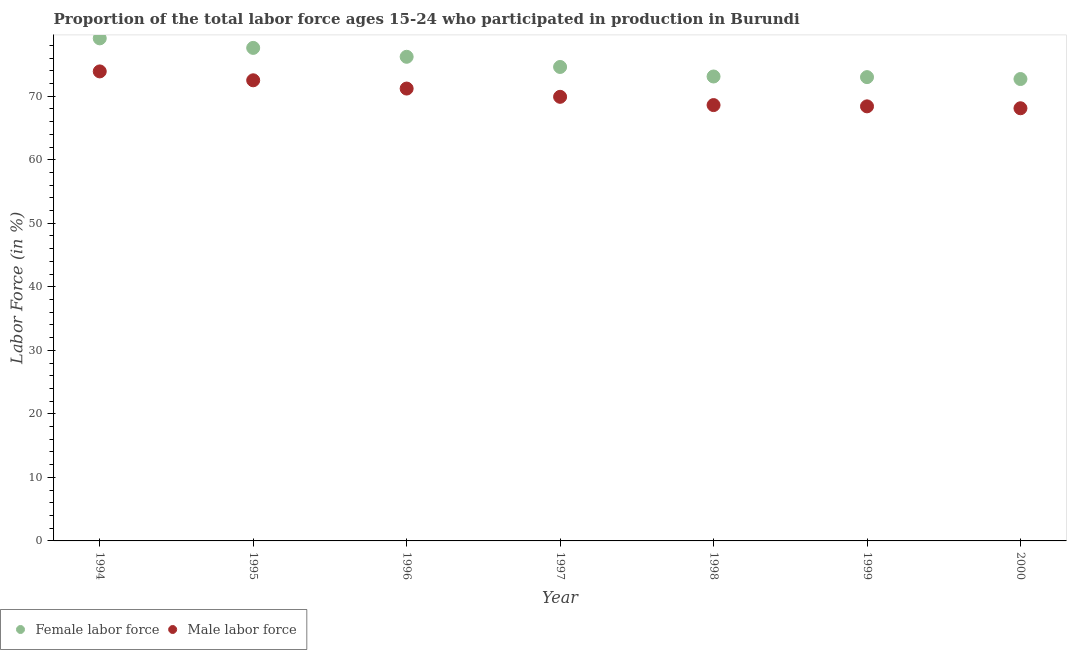Is the number of dotlines equal to the number of legend labels?
Offer a terse response. Yes. What is the percentage of male labour force in 1999?
Keep it short and to the point. 68.4. Across all years, what is the maximum percentage of male labour force?
Provide a short and direct response. 73.9. Across all years, what is the minimum percentage of female labor force?
Your answer should be compact. 72.7. In which year was the percentage of male labour force maximum?
Make the answer very short. 1994. In which year was the percentage of female labor force minimum?
Your answer should be compact. 2000. What is the total percentage of male labour force in the graph?
Make the answer very short. 492.6. What is the difference between the percentage of male labour force in 1994 and that in 1997?
Keep it short and to the point. 4. What is the difference between the percentage of male labour force in 1999 and the percentage of female labor force in 1998?
Offer a very short reply. -4.7. What is the average percentage of male labour force per year?
Ensure brevity in your answer.  70.37. In the year 1999, what is the difference between the percentage of female labor force and percentage of male labour force?
Your answer should be compact. 4.6. What is the ratio of the percentage of male labour force in 1994 to that in 1998?
Ensure brevity in your answer.  1.08. Is the percentage of female labor force in 1998 less than that in 2000?
Provide a succinct answer. No. Is the difference between the percentage of male labour force in 1996 and 1998 greater than the difference between the percentage of female labor force in 1996 and 1998?
Provide a short and direct response. No. What is the difference between the highest and the second highest percentage of male labour force?
Offer a very short reply. 1.4. What is the difference between the highest and the lowest percentage of female labor force?
Ensure brevity in your answer.  6.4. Is the percentage of male labour force strictly greater than the percentage of female labor force over the years?
Your response must be concise. No. How many years are there in the graph?
Provide a succinct answer. 7. Are the values on the major ticks of Y-axis written in scientific E-notation?
Your answer should be very brief. No. Does the graph contain any zero values?
Your response must be concise. No. Where does the legend appear in the graph?
Offer a terse response. Bottom left. How many legend labels are there?
Your answer should be very brief. 2. How are the legend labels stacked?
Offer a very short reply. Horizontal. What is the title of the graph?
Your answer should be very brief. Proportion of the total labor force ages 15-24 who participated in production in Burundi. What is the label or title of the X-axis?
Your response must be concise. Year. What is the Labor Force (in %) in Female labor force in 1994?
Your answer should be compact. 79.1. What is the Labor Force (in %) in Male labor force in 1994?
Make the answer very short. 73.9. What is the Labor Force (in %) of Female labor force in 1995?
Offer a terse response. 77.6. What is the Labor Force (in %) in Male labor force in 1995?
Your answer should be very brief. 72.5. What is the Labor Force (in %) of Female labor force in 1996?
Make the answer very short. 76.2. What is the Labor Force (in %) of Male labor force in 1996?
Your answer should be very brief. 71.2. What is the Labor Force (in %) of Female labor force in 1997?
Make the answer very short. 74.6. What is the Labor Force (in %) of Male labor force in 1997?
Offer a very short reply. 69.9. What is the Labor Force (in %) of Female labor force in 1998?
Give a very brief answer. 73.1. What is the Labor Force (in %) in Male labor force in 1998?
Keep it short and to the point. 68.6. What is the Labor Force (in %) in Male labor force in 1999?
Ensure brevity in your answer.  68.4. What is the Labor Force (in %) in Female labor force in 2000?
Provide a short and direct response. 72.7. What is the Labor Force (in %) of Male labor force in 2000?
Provide a succinct answer. 68.1. Across all years, what is the maximum Labor Force (in %) of Female labor force?
Offer a terse response. 79.1. Across all years, what is the maximum Labor Force (in %) of Male labor force?
Give a very brief answer. 73.9. Across all years, what is the minimum Labor Force (in %) of Female labor force?
Provide a short and direct response. 72.7. Across all years, what is the minimum Labor Force (in %) in Male labor force?
Give a very brief answer. 68.1. What is the total Labor Force (in %) of Female labor force in the graph?
Ensure brevity in your answer.  526.3. What is the total Labor Force (in %) in Male labor force in the graph?
Ensure brevity in your answer.  492.6. What is the difference between the Labor Force (in %) of Female labor force in 1994 and that in 1996?
Provide a short and direct response. 2.9. What is the difference between the Labor Force (in %) in Female labor force in 1994 and that in 1997?
Provide a short and direct response. 4.5. What is the difference between the Labor Force (in %) in Male labor force in 1994 and that in 1998?
Ensure brevity in your answer.  5.3. What is the difference between the Labor Force (in %) of Male labor force in 1994 and that in 2000?
Provide a succinct answer. 5.8. What is the difference between the Labor Force (in %) of Female labor force in 1995 and that in 1996?
Provide a short and direct response. 1.4. What is the difference between the Labor Force (in %) of Male labor force in 1995 and that in 1997?
Keep it short and to the point. 2.6. What is the difference between the Labor Force (in %) in Female labor force in 1995 and that in 1998?
Your response must be concise. 4.5. What is the difference between the Labor Force (in %) of Male labor force in 1995 and that in 2000?
Provide a short and direct response. 4.4. What is the difference between the Labor Force (in %) in Female labor force in 1996 and that in 1997?
Provide a succinct answer. 1.6. What is the difference between the Labor Force (in %) in Male labor force in 1996 and that in 1999?
Give a very brief answer. 2.8. What is the difference between the Labor Force (in %) in Female labor force in 1996 and that in 2000?
Your answer should be very brief. 3.5. What is the difference between the Labor Force (in %) of Male labor force in 1996 and that in 2000?
Make the answer very short. 3.1. What is the difference between the Labor Force (in %) in Female labor force in 1997 and that in 1998?
Make the answer very short. 1.5. What is the difference between the Labor Force (in %) of Male labor force in 1997 and that in 1998?
Keep it short and to the point. 1.3. What is the difference between the Labor Force (in %) of Male labor force in 1997 and that in 1999?
Ensure brevity in your answer.  1.5. What is the difference between the Labor Force (in %) of Female labor force in 1998 and that in 1999?
Make the answer very short. 0.1. What is the difference between the Labor Force (in %) of Male labor force in 1998 and that in 1999?
Provide a succinct answer. 0.2. What is the difference between the Labor Force (in %) of Male labor force in 1998 and that in 2000?
Make the answer very short. 0.5. What is the difference between the Labor Force (in %) in Male labor force in 1999 and that in 2000?
Offer a very short reply. 0.3. What is the difference between the Labor Force (in %) of Female labor force in 1994 and the Labor Force (in %) of Male labor force in 1996?
Offer a very short reply. 7.9. What is the difference between the Labor Force (in %) in Female labor force in 1994 and the Labor Force (in %) in Male labor force in 1997?
Your answer should be very brief. 9.2. What is the difference between the Labor Force (in %) of Female labor force in 1995 and the Labor Force (in %) of Male labor force in 1996?
Your response must be concise. 6.4. What is the difference between the Labor Force (in %) in Female labor force in 1995 and the Labor Force (in %) in Male labor force in 2000?
Your answer should be very brief. 9.5. What is the difference between the Labor Force (in %) in Female labor force in 1996 and the Labor Force (in %) in Male labor force in 1997?
Offer a terse response. 6.3. What is the difference between the Labor Force (in %) in Female labor force in 1996 and the Labor Force (in %) in Male labor force in 1999?
Provide a short and direct response. 7.8. What is the difference between the Labor Force (in %) of Female labor force in 1998 and the Labor Force (in %) of Male labor force in 2000?
Offer a terse response. 5. What is the difference between the Labor Force (in %) of Female labor force in 1999 and the Labor Force (in %) of Male labor force in 2000?
Your answer should be very brief. 4.9. What is the average Labor Force (in %) of Female labor force per year?
Your response must be concise. 75.19. What is the average Labor Force (in %) of Male labor force per year?
Provide a short and direct response. 70.37. In the year 1994, what is the difference between the Labor Force (in %) in Female labor force and Labor Force (in %) in Male labor force?
Offer a terse response. 5.2. In the year 1995, what is the difference between the Labor Force (in %) of Female labor force and Labor Force (in %) of Male labor force?
Offer a very short reply. 5.1. In the year 1996, what is the difference between the Labor Force (in %) in Female labor force and Labor Force (in %) in Male labor force?
Keep it short and to the point. 5. In the year 1997, what is the difference between the Labor Force (in %) of Female labor force and Labor Force (in %) of Male labor force?
Your response must be concise. 4.7. In the year 1998, what is the difference between the Labor Force (in %) of Female labor force and Labor Force (in %) of Male labor force?
Offer a terse response. 4.5. What is the ratio of the Labor Force (in %) of Female labor force in 1994 to that in 1995?
Your answer should be compact. 1.02. What is the ratio of the Labor Force (in %) in Male labor force in 1994 to that in 1995?
Ensure brevity in your answer.  1.02. What is the ratio of the Labor Force (in %) of Female labor force in 1994 to that in 1996?
Offer a very short reply. 1.04. What is the ratio of the Labor Force (in %) of Male labor force in 1994 to that in 1996?
Ensure brevity in your answer.  1.04. What is the ratio of the Labor Force (in %) in Female labor force in 1994 to that in 1997?
Your answer should be compact. 1.06. What is the ratio of the Labor Force (in %) in Male labor force in 1994 to that in 1997?
Your answer should be very brief. 1.06. What is the ratio of the Labor Force (in %) in Female labor force in 1994 to that in 1998?
Keep it short and to the point. 1.08. What is the ratio of the Labor Force (in %) in Male labor force in 1994 to that in 1998?
Give a very brief answer. 1.08. What is the ratio of the Labor Force (in %) of Female labor force in 1994 to that in 1999?
Provide a succinct answer. 1.08. What is the ratio of the Labor Force (in %) in Male labor force in 1994 to that in 1999?
Offer a very short reply. 1.08. What is the ratio of the Labor Force (in %) in Female labor force in 1994 to that in 2000?
Offer a terse response. 1.09. What is the ratio of the Labor Force (in %) of Male labor force in 1994 to that in 2000?
Your response must be concise. 1.09. What is the ratio of the Labor Force (in %) of Female labor force in 1995 to that in 1996?
Make the answer very short. 1.02. What is the ratio of the Labor Force (in %) in Male labor force in 1995 to that in 1996?
Provide a short and direct response. 1.02. What is the ratio of the Labor Force (in %) of Female labor force in 1995 to that in 1997?
Your response must be concise. 1.04. What is the ratio of the Labor Force (in %) of Male labor force in 1995 to that in 1997?
Offer a terse response. 1.04. What is the ratio of the Labor Force (in %) in Female labor force in 1995 to that in 1998?
Give a very brief answer. 1.06. What is the ratio of the Labor Force (in %) of Male labor force in 1995 to that in 1998?
Provide a succinct answer. 1.06. What is the ratio of the Labor Force (in %) in Female labor force in 1995 to that in 1999?
Your answer should be very brief. 1.06. What is the ratio of the Labor Force (in %) in Male labor force in 1995 to that in 1999?
Offer a terse response. 1.06. What is the ratio of the Labor Force (in %) in Female labor force in 1995 to that in 2000?
Ensure brevity in your answer.  1.07. What is the ratio of the Labor Force (in %) of Male labor force in 1995 to that in 2000?
Keep it short and to the point. 1.06. What is the ratio of the Labor Force (in %) of Female labor force in 1996 to that in 1997?
Make the answer very short. 1.02. What is the ratio of the Labor Force (in %) of Male labor force in 1996 to that in 1997?
Offer a very short reply. 1.02. What is the ratio of the Labor Force (in %) of Female labor force in 1996 to that in 1998?
Your answer should be compact. 1.04. What is the ratio of the Labor Force (in %) of Male labor force in 1996 to that in 1998?
Offer a terse response. 1.04. What is the ratio of the Labor Force (in %) in Female labor force in 1996 to that in 1999?
Your answer should be compact. 1.04. What is the ratio of the Labor Force (in %) in Male labor force in 1996 to that in 1999?
Make the answer very short. 1.04. What is the ratio of the Labor Force (in %) in Female labor force in 1996 to that in 2000?
Provide a short and direct response. 1.05. What is the ratio of the Labor Force (in %) of Male labor force in 1996 to that in 2000?
Keep it short and to the point. 1.05. What is the ratio of the Labor Force (in %) of Female labor force in 1997 to that in 1998?
Provide a short and direct response. 1.02. What is the ratio of the Labor Force (in %) in Female labor force in 1997 to that in 1999?
Provide a short and direct response. 1.02. What is the ratio of the Labor Force (in %) in Male labor force in 1997 to that in 1999?
Provide a short and direct response. 1.02. What is the ratio of the Labor Force (in %) in Female labor force in 1997 to that in 2000?
Your answer should be compact. 1.03. What is the ratio of the Labor Force (in %) in Male labor force in 1997 to that in 2000?
Your answer should be compact. 1.03. What is the ratio of the Labor Force (in %) of Female labor force in 1998 to that in 1999?
Your response must be concise. 1. What is the ratio of the Labor Force (in %) in Male labor force in 1998 to that in 2000?
Your answer should be compact. 1.01. What is the ratio of the Labor Force (in %) of Female labor force in 1999 to that in 2000?
Ensure brevity in your answer.  1. 